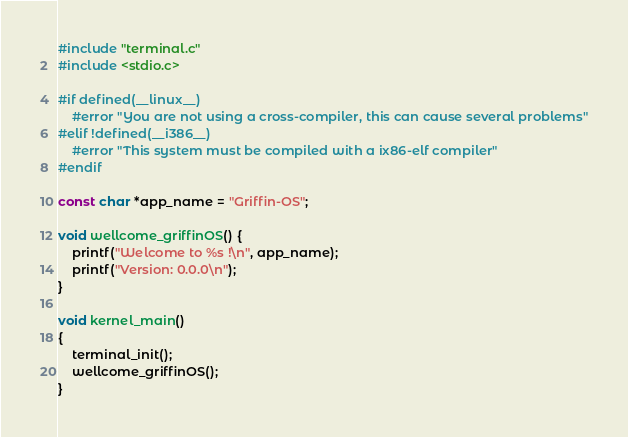Convert code to text. <code><loc_0><loc_0><loc_500><loc_500><_C_>#include "terminal.c"
#include <stdio.c>
 
#if defined(__linux__)
	#error "You are not using a cross-compiler, this can cause several problems"
#elif !defined(__i386__)
	#error "This system must be compiled with a ix86-elf compiler"
#endif

const char *app_name = "Griffin-OS";

void wellcome_griffinOS() {
	printf("Welcome to %s !\n", app_name);
	printf("Version: 0.0.0\n");
}

void kernel_main()
{
    terminal_init();
    wellcome_griffinOS();
}</code> 